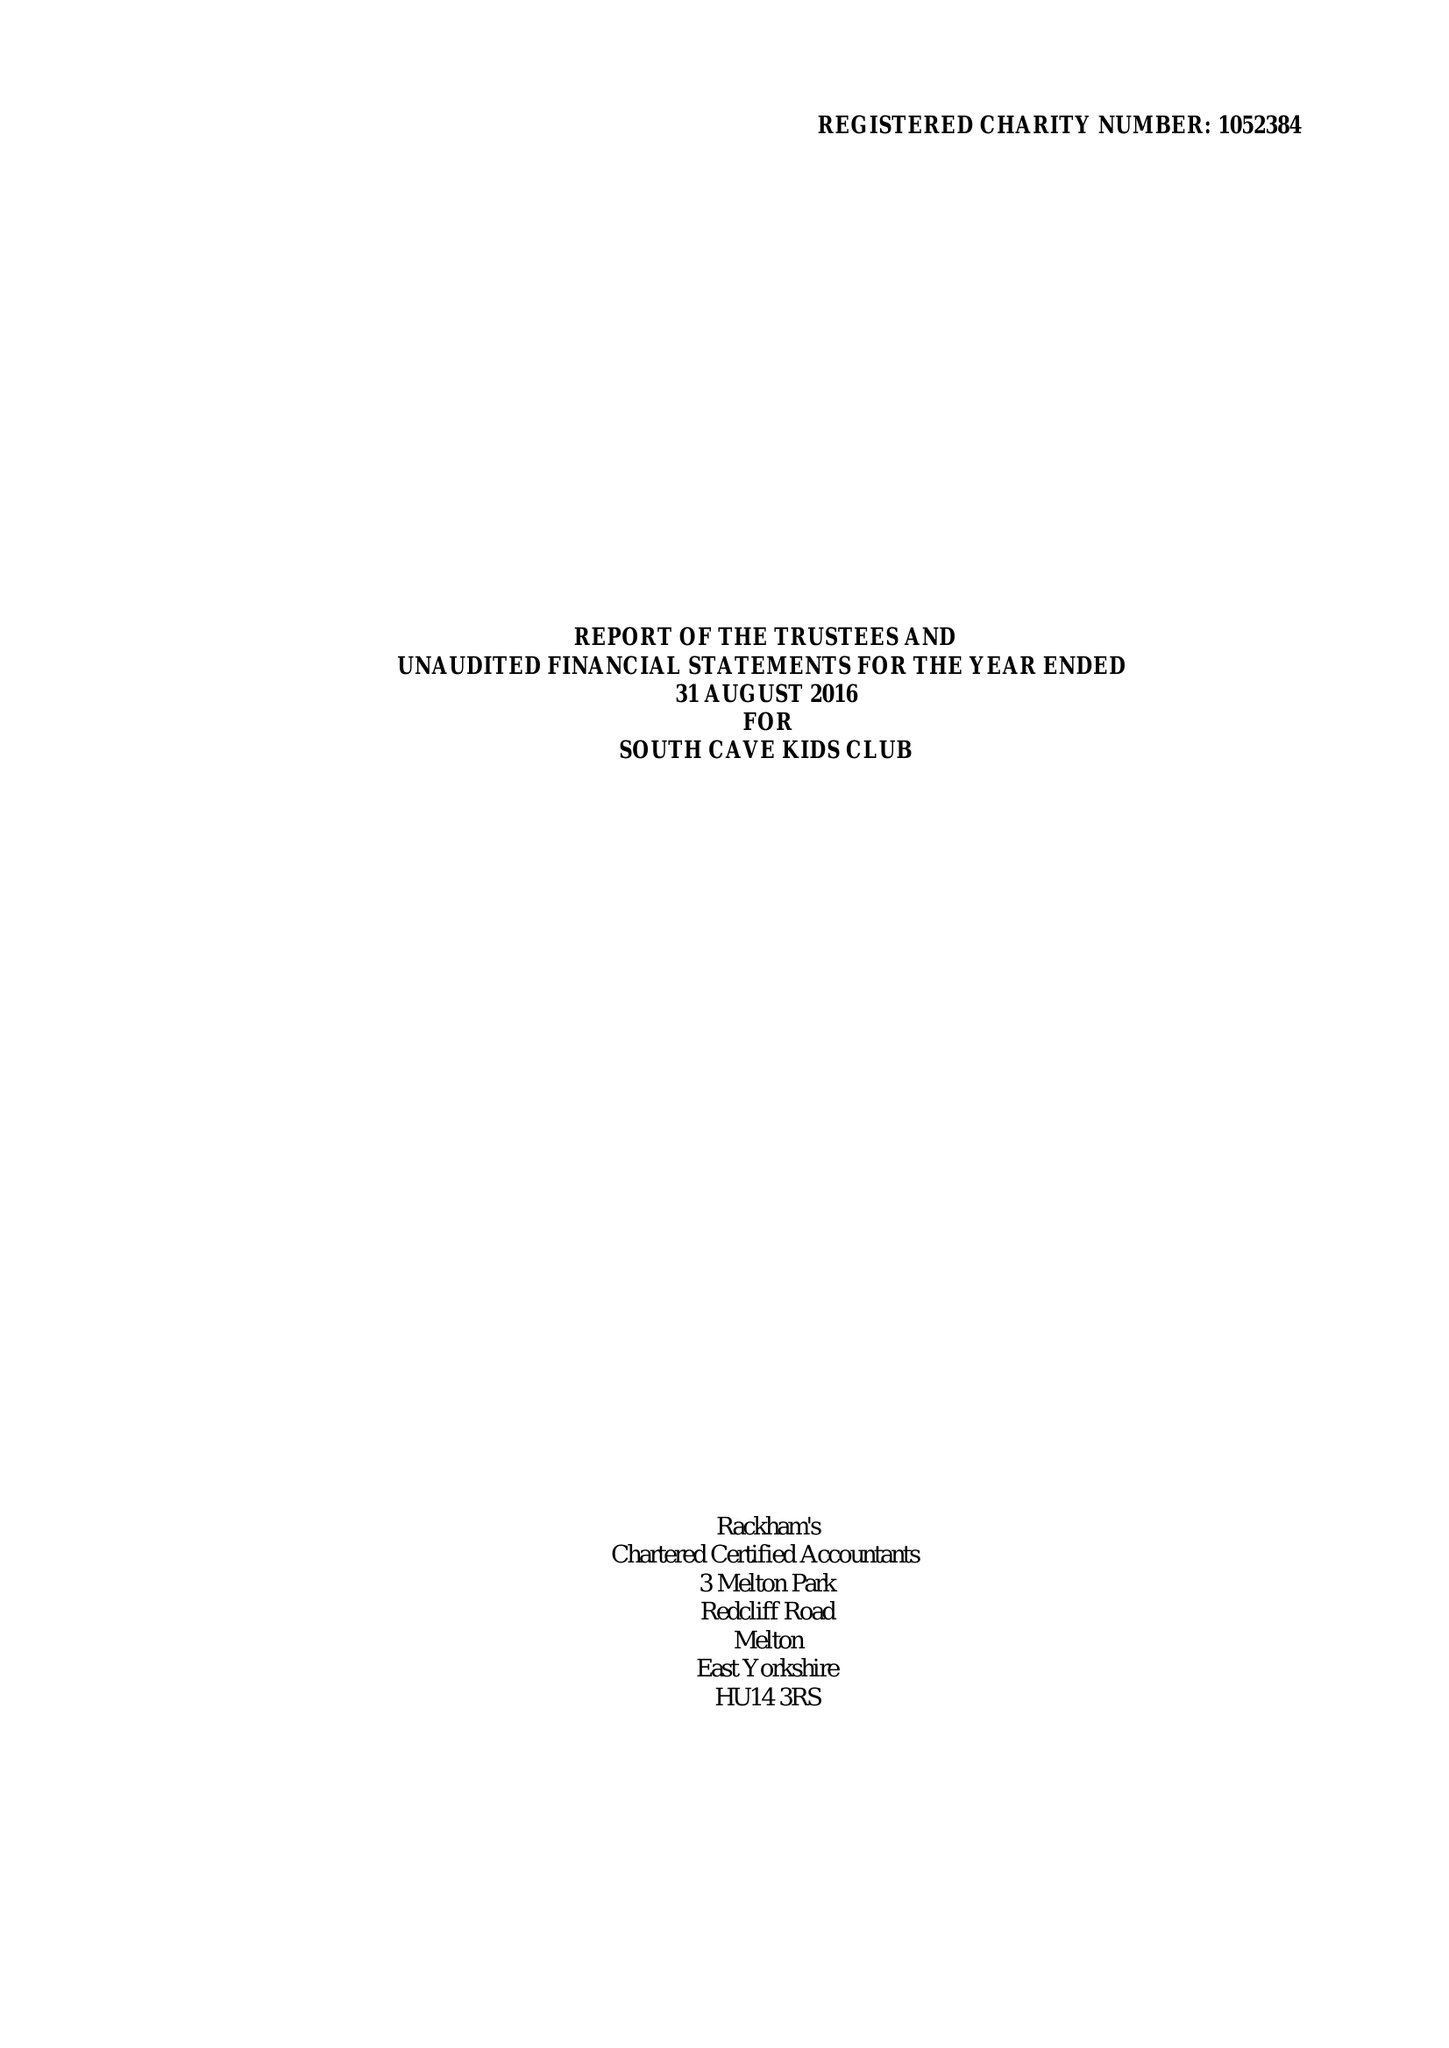What is the value for the charity_name?
Answer the question using a single word or phrase. South Cave Kids Club 